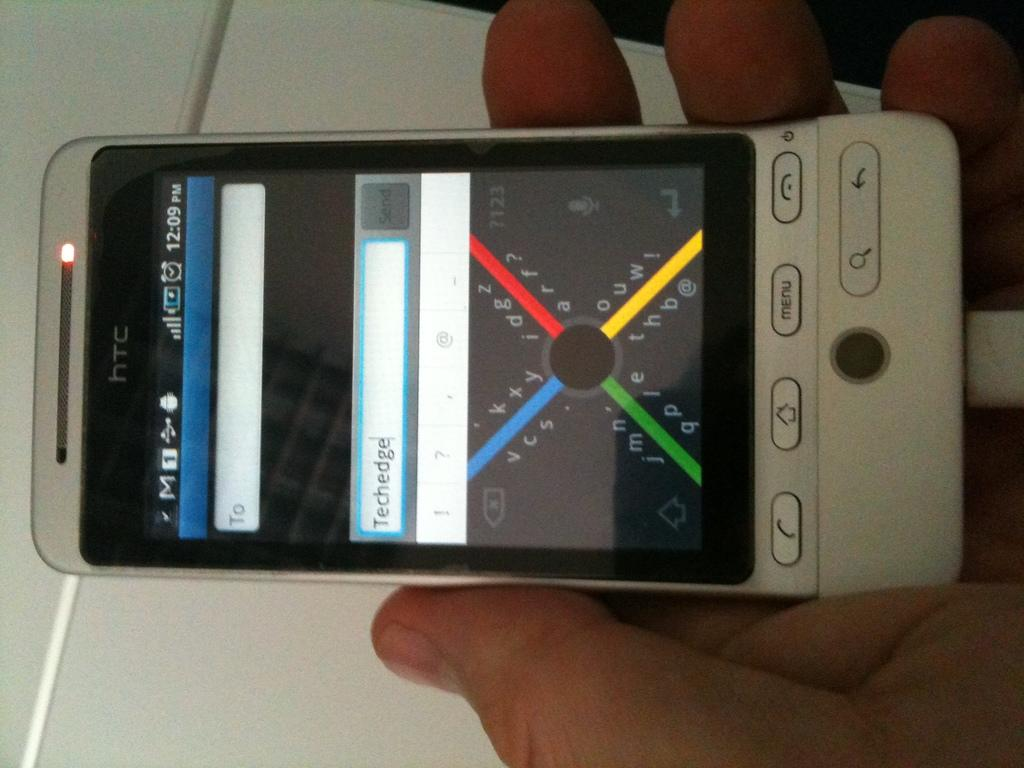Provide a one-sentence caption for the provided image. A grey smartphone with a red, blue, green and yellow X on the screen that is being held. 